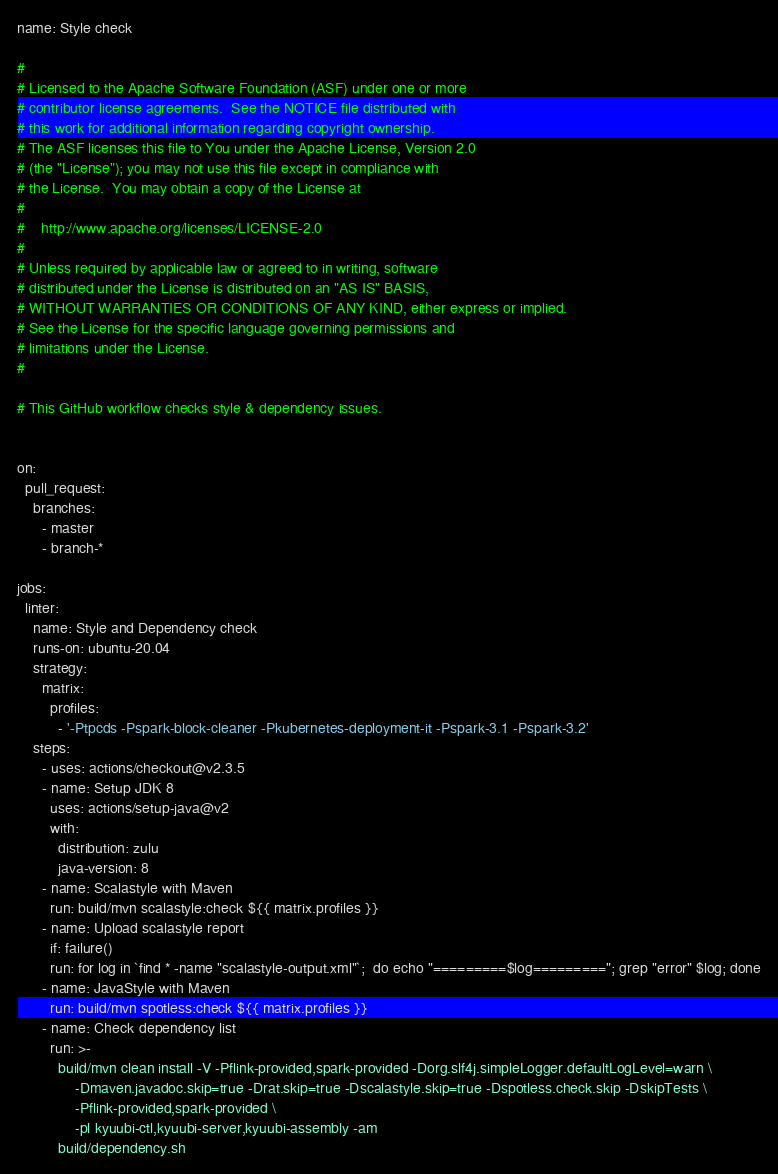Convert code to text. <code><loc_0><loc_0><loc_500><loc_500><_YAML_>name: Style check

#
# Licensed to the Apache Software Foundation (ASF) under one or more
# contributor license agreements.  See the NOTICE file distributed with
# this work for additional information regarding copyright ownership.
# The ASF licenses this file to You under the Apache License, Version 2.0
# (the "License"); you may not use this file except in compliance with
# the License.  You may obtain a copy of the License at
#
#    http://www.apache.org/licenses/LICENSE-2.0
#
# Unless required by applicable law or agreed to in writing, software
# distributed under the License is distributed on an "AS IS" BASIS,
# WITHOUT WARRANTIES OR CONDITIONS OF ANY KIND, either express or implied.
# See the License for the specific language governing permissions and
# limitations under the License.
#

# This GitHub workflow checks style & dependency issues.


on:
  pull_request:
    branches:
      - master
      - branch-*

jobs:
  linter:
    name: Style and Dependency check
    runs-on: ubuntu-20.04
    strategy:
      matrix:
        profiles:
          - '-Ptpcds -Pspark-block-cleaner -Pkubernetes-deployment-it -Pspark-3.1 -Pspark-3.2'
    steps:
      - uses: actions/checkout@v2.3.5
      - name: Setup JDK 8
        uses: actions/setup-java@v2
        with:
          distribution: zulu
          java-version: 8
      - name: Scalastyle with Maven
        run: build/mvn scalastyle:check ${{ matrix.profiles }}
      - name: Upload scalastyle report
        if: failure()
        run: for log in `find * -name "scalastyle-output.xml"`;  do echo "=========$log========="; grep "error" $log; done
      - name: JavaStyle with Maven
        run: build/mvn spotless:check ${{ matrix.profiles }}
      - name: Check dependency list
        run: >-
          build/mvn clean install -V -Pflink-provided,spark-provided -Dorg.slf4j.simpleLogger.defaultLogLevel=warn \
              -Dmaven.javadoc.skip=true -Drat.skip=true -Dscalastyle.skip=true -Dspotless.check.skip -DskipTests \
              -Pflink-provided,spark-provided \
              -pl kyuubi-ctl,kyuubi-server,kyuubi-assembly -am
          build/dependency.sh
</code> 